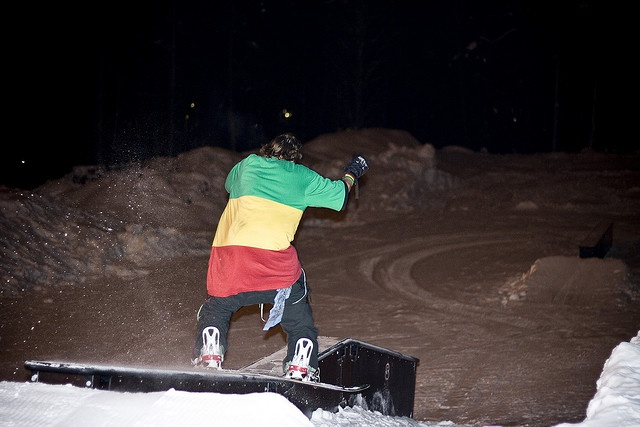Describe the objects in this image and their specific colors. I can see people in black, salmon, khaki, and turquoise tones and snowboard in black, darkgray, gray, and lightgray tones in this image. 